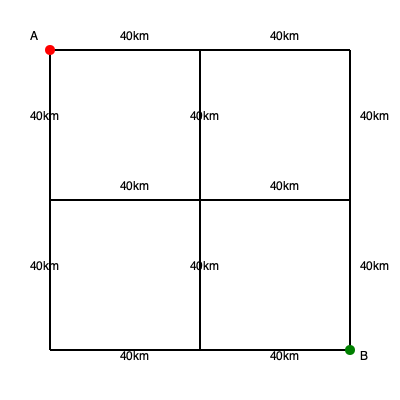Given the road network shown in the diagram, where each segment represents 40km, what is the shortest distance in kilometers for troop deployment from point A to point B? To find the shortest distance from point A to point B, we need to analyze the possible routes:

1. Diagonal route:
   - This would be the shortest path if it existed, but there's no direct diagonal road.

2. Manhattan distance:
   - Moving only horizontally and vertically, we have two equivalent options:
     a) Right 2 segments, then down 2 segments
     b) Down 2 segments, then right 2 segments
   - Each of these routes covers 4 segments.

3. Alternative routes:
   - Any other route would involve more than 4 segments, making it longer.

Calculation:
- Each segment is 40km
- The shortest path uses 4 segments
- Total distance = $4 \times 40\text{km} = 160\text{km}$

Therefore, the shortest distance for troop deployment from A to B is 160km.
Answer: 160km 